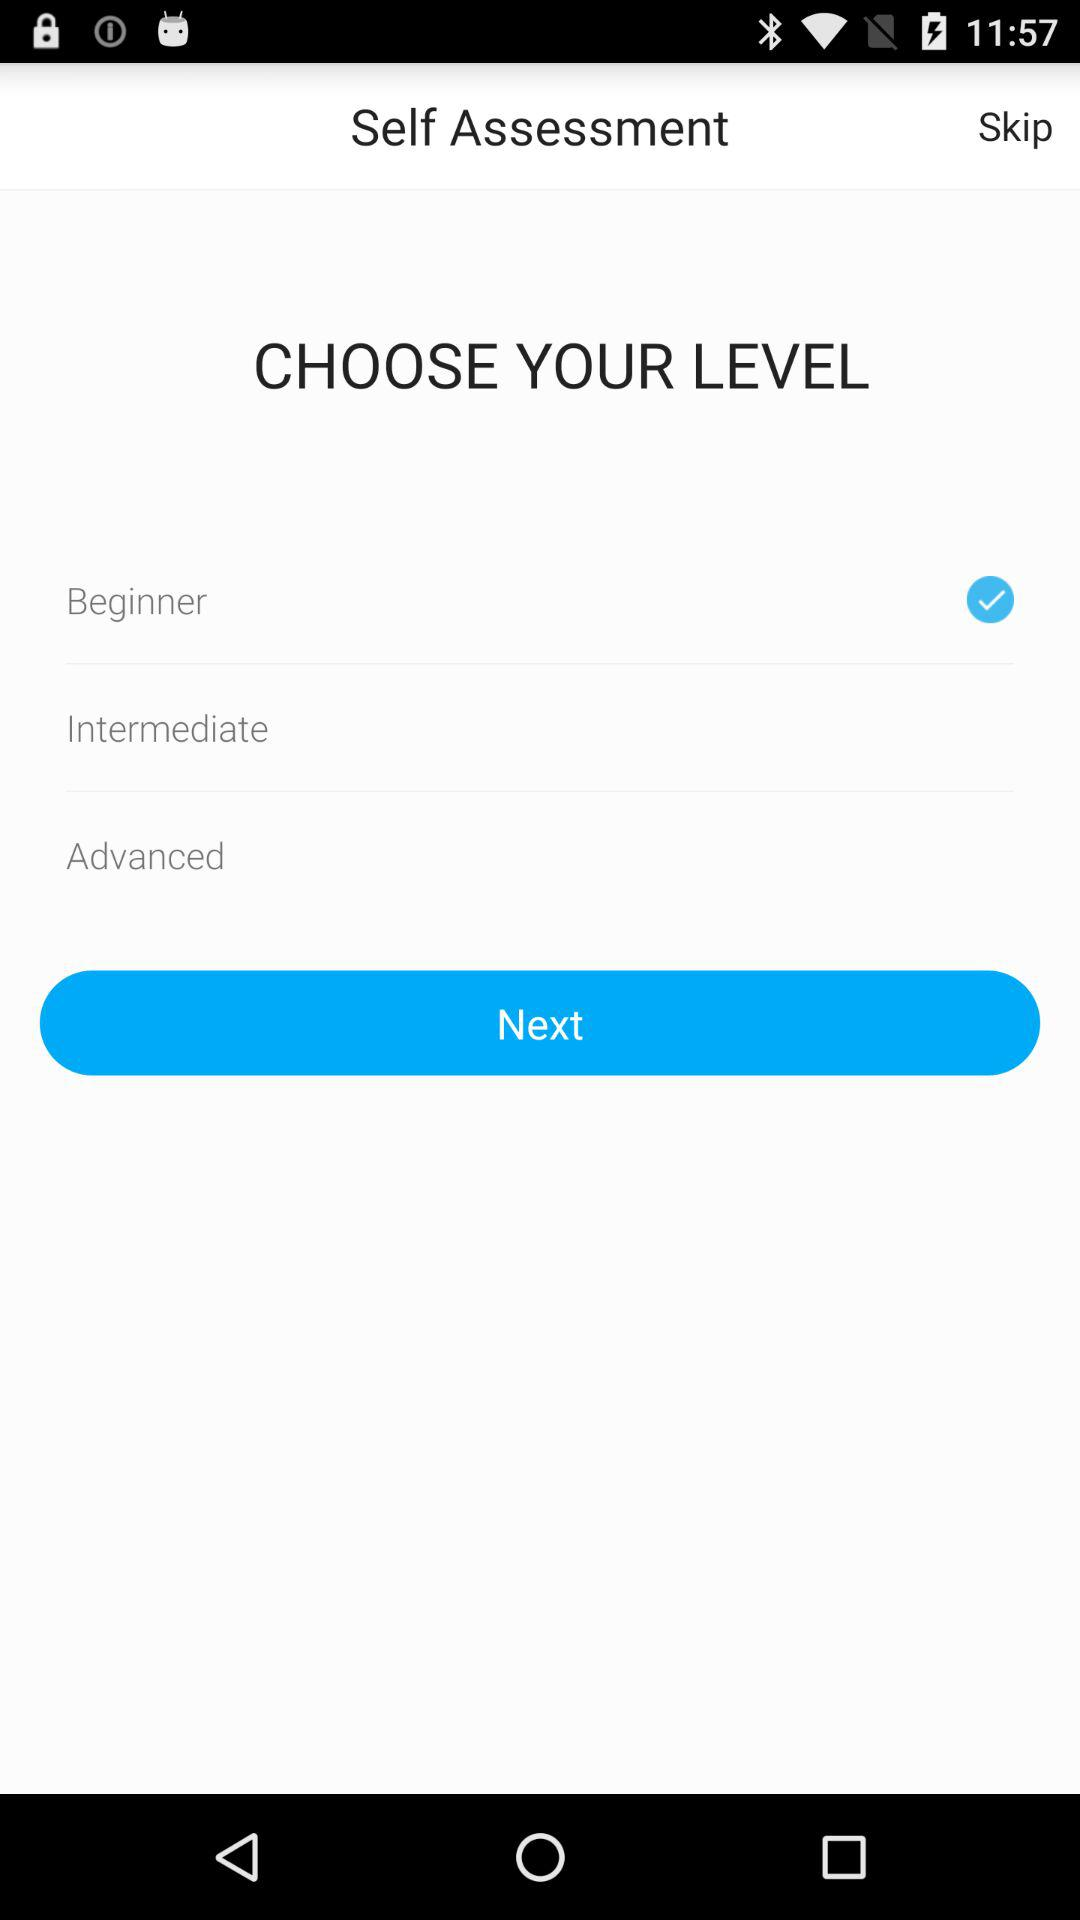How many levels are there in the self assessment screen?
Answer the question using a single word or phrase. 3 